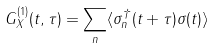Convert formula to latex. <formula><loc_0><loc_0><loc_500><loc_500>G ^ { ( 1 ) } _ { X } ( t , \tau ) = \sum _ { n } \langle \sigma ^ { \dagger } _ { n } ( t + \tau ) \sigma ( t ) \rangle</formula> 